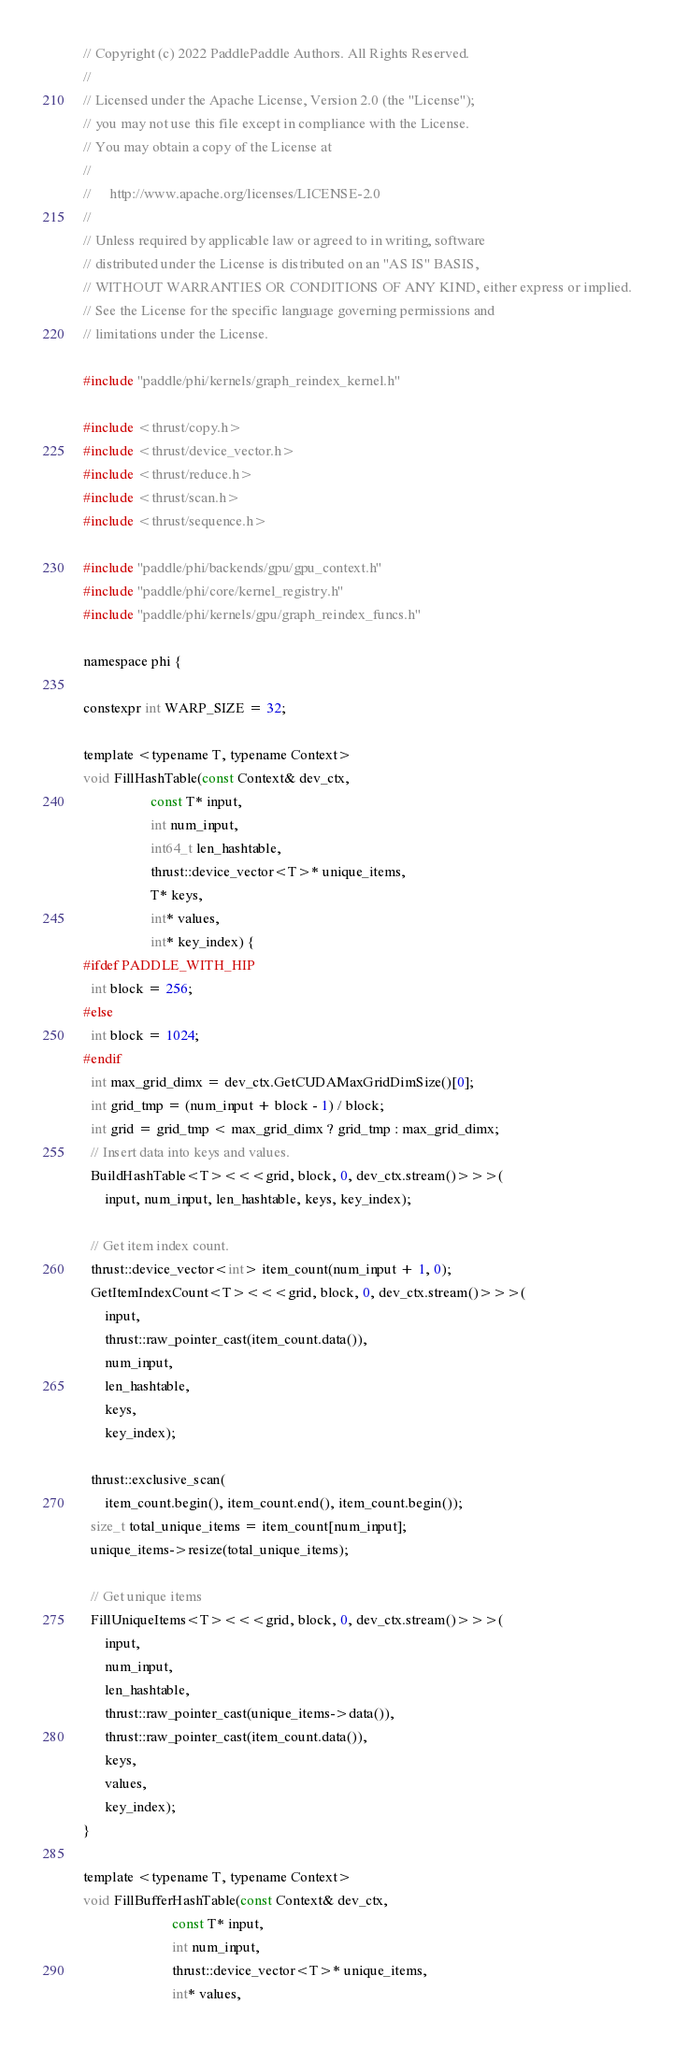Convert code to text. <code><loc_0><loc_0><loc_500><loc_500><_Cuda_>// Copyright (c) 2022 PaddlePaddle Authors. All Rights Reserved.
//
// Licensed under the Apache License, Version 2.0 (the "License");
// you may not use this file except in compliance with the License.
// You may obtain a copy of the License at
//
//     http://www.apache.org/licenses/LICENSE-2.0
//
// Unless required by applicable law or agreed to in writing, software
// distributed under the License is distributed on an "AS IS" BASIS,
// WITHOUT WARRANTIES OR CONDITIONS OF ANY KIND, either express or implied.
// See the License for the specific language governing permissions and
// limitations under the License.

#include "paddle/phi/kernels/graph_reindex_kernel.h"

#include <thrust/copy.h>
#include <thrust/device_vector.h>
#include <thrust/reduce.h>
#include <thrust/scan.h>
#include <thrust/sequence.h>

#include "paddle/phi/backends/gpu/gpu_context.h"
#include "paddle/phi/core/kernel_registry.h"
#include "paddle/phi/kernels/gpu/graph_reindex_funcs.h"

namespace phi {

constexpr int WARP_SIZE = 32;

template <typename T, typename Context>
void FillHashTable(const Context& dev_ctx,
                   const T* input,
                   int num_input,
                   int64_t len_hashtable,
                   thrust::device_vector<T>* unique_items,
                   T* keys,
                   int* values,
                   int* key_index) {
#ifdef PADDLE_WITH_HIP
  int block = 256;
#else
  int block = 1024;
#endif
  int max_grid_dimx = dev_ctx.GetCUDAMaxGridDimSize()[0];
  int grid_tmp = (num_input + block - 1) / block;
  int grid = grid_tmp < max_grid_dimx ? grid_tmp : max_grid_dimx;
  // Insert data into keys and values.
  BuildHashTable<T><<<grid, block, 0, dev_ctx.stream()>>>(
      input, num_input, len_hashtable, keys, key_index);

  // Get item index count.
  thrust::device_vector<int> item_count(num_input + 1, 0);
  GetItemIndexCount<T><<<grid, block, 0, dev_ctx.stream()>>>(
      input,
      thrust::raw_pointer_cast(item_count.data()),
      num_input,
      len_hashtable,
      keys,
      key_index);

  thrust::exclusive_scan(
      item_count.begin(), item_count.end(), item_count.begin());
  size_t total_unique_items = item_count[num_input];
  unique_items->resize(total_unique_items);

  // Get unique items
  FillUniqueItems<T><<<grid, block, 0, dev_ctx.stream()>>>(
      input,
      num_input,
      len_hashtable,
      thrust::raw_pointer_cast(unique_items->data()),
      thrust::raw_pointer_cast(item_count.data()),
      keys,
      values,
      key_index);
}

template <typename T, typename Context>
void FillBufferHashTable(const Context& dev_ctx,
                         const T* input,
                         int num_input,
                         thrust::device_vector<T>* unique_items,
                         int* values,</code> 